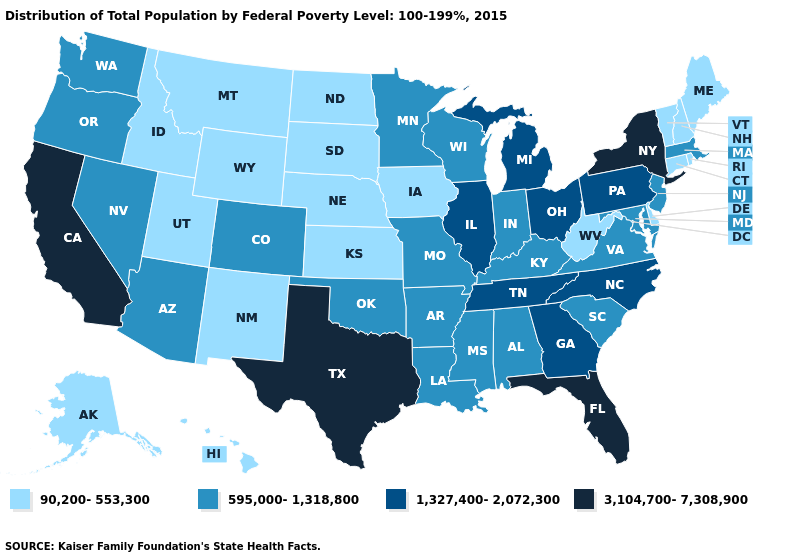Which states hav the highest value in the West?
Quick response, please. California. What is the highest value in the West ?
Write a very short answer. 3,104,700-7,308,900. Which states hav the highest value in the Northeast?
Be succinct. New York. What is the value of Montana?
Write a very short answer. 90,200-553,300. Name the states that have a value in the range 90,200-553,300?
Short answer required. Alaska, Connecticut, Delaware, Hawaii, Idaho, Iowa, Kansas, Maine, Montana, Nebraska, New Hampshire, New Mexico, North Dakota, Rhode Island, South Dakota, Utah, Vermont, West Virginia, Wyoming. Does Texas have the highest value in the South?
Be succinct. Yes. Does the map have missing data?
Be succinct. No. Name the states that have a value in the range 3,104,700-7,308,900?
Quick response, please. California, Florida, New York, Texas. What is the lowest value in states that border Oklahoma?
Concise answer only. 90,200-553,300. What is the lowest value in states that border Kentucky?
Answer briefly. 90,200-553,300. What is the lowest value in the MidWest?
Short answer required. 90,200-553,300. What is the highest value in the South ?
Concise answer only. 3,104,700-7,308,900. Among the states that border Alabama , does Mississippi have the lowest value?
Give a very brief answer. Yes. What is the highest value in the USA?
Be succinct. 3,104,700-7,308,900. Which states have the lowest value in the South?
Keep it brief. Delaware, West Virginia. 